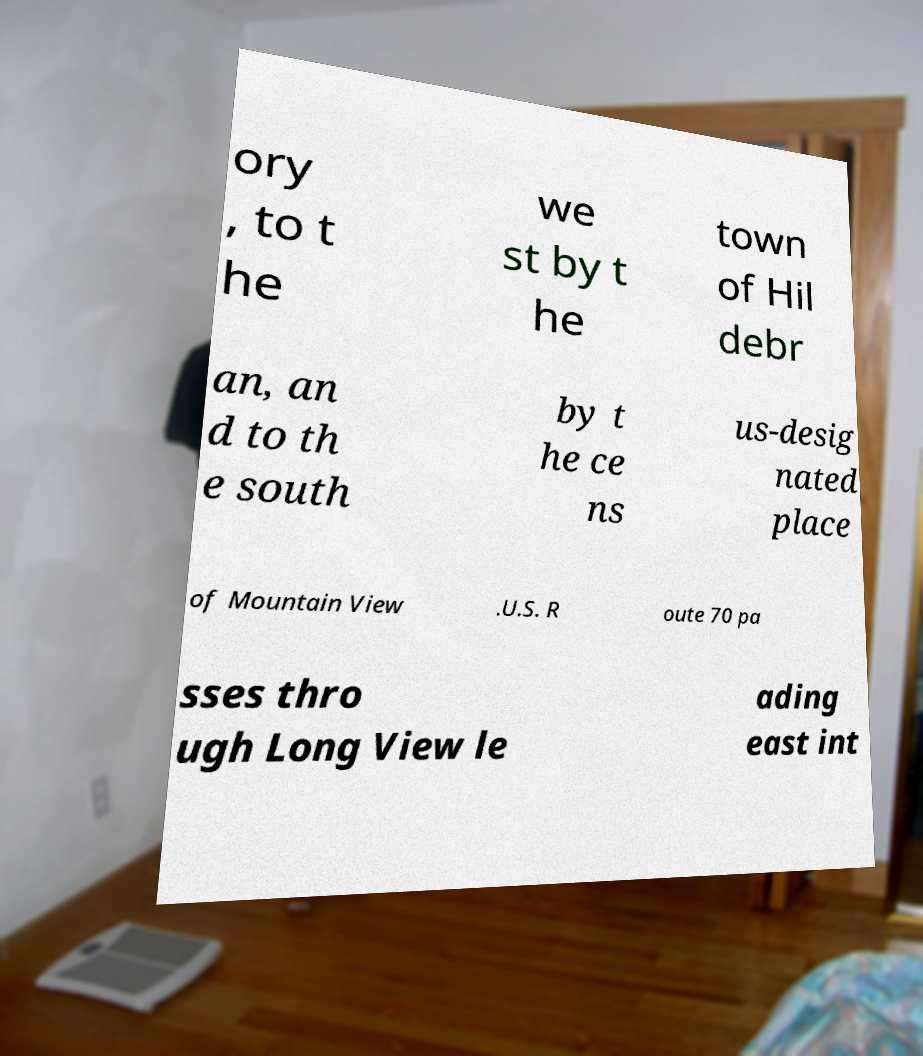What messages or text are displayed in this image? I need them in a readable, typed format. ory , to t he we st by t he town of Hil debr an, an d to th e south by t he ce ns us-desig nated place of Mountain View .U.S. R oute 70 pa sses thro ugh Long View le ading east int 